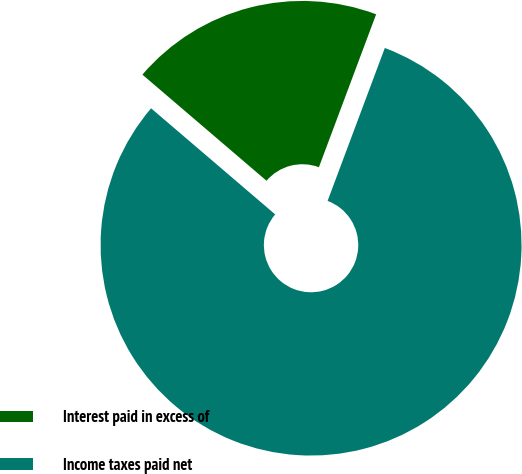Convert chart. <chart><loc_0><loc_0><loc_500><loc_500><pie_chart><fcel>Interest paid in excess of<fcel>Income taxes paid net<nl><fcel>19.44%<fcel>80.56%<nl></chart> 